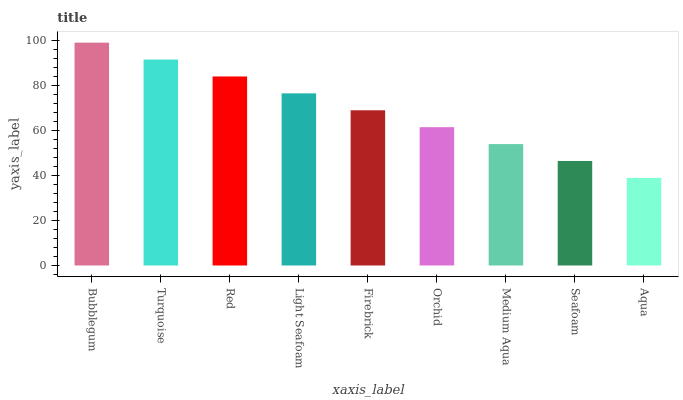Is Aqua the minimum?
Answer yes or no. Yes. Is Bubblegum the maximum?
Answer yes or no. Yes. Is Turquoise the minimum?
Answer yes or no. No. Is Turquoise the maximum?
Answer yes or no. No. Is Bubblegum greater than Turquoise?
Answer yes or no. Yes. Is Turquoise less than Bubblegum?
Answer yes or no. Yes. Is Turquoise greater than Bubblegum?
Answer yes or no. No. Is Bubblegum less than Turquoise?
Answer yes or no. No. Is Firebrick the high median?
Answer yes or no. Yes. Is Firebrick the low median?
Answer yes or no. Yes. Is Bubblegum the high median?
Answer yes or no. No. Is Medium Aqua the low median?
Answer yes or no. No. 